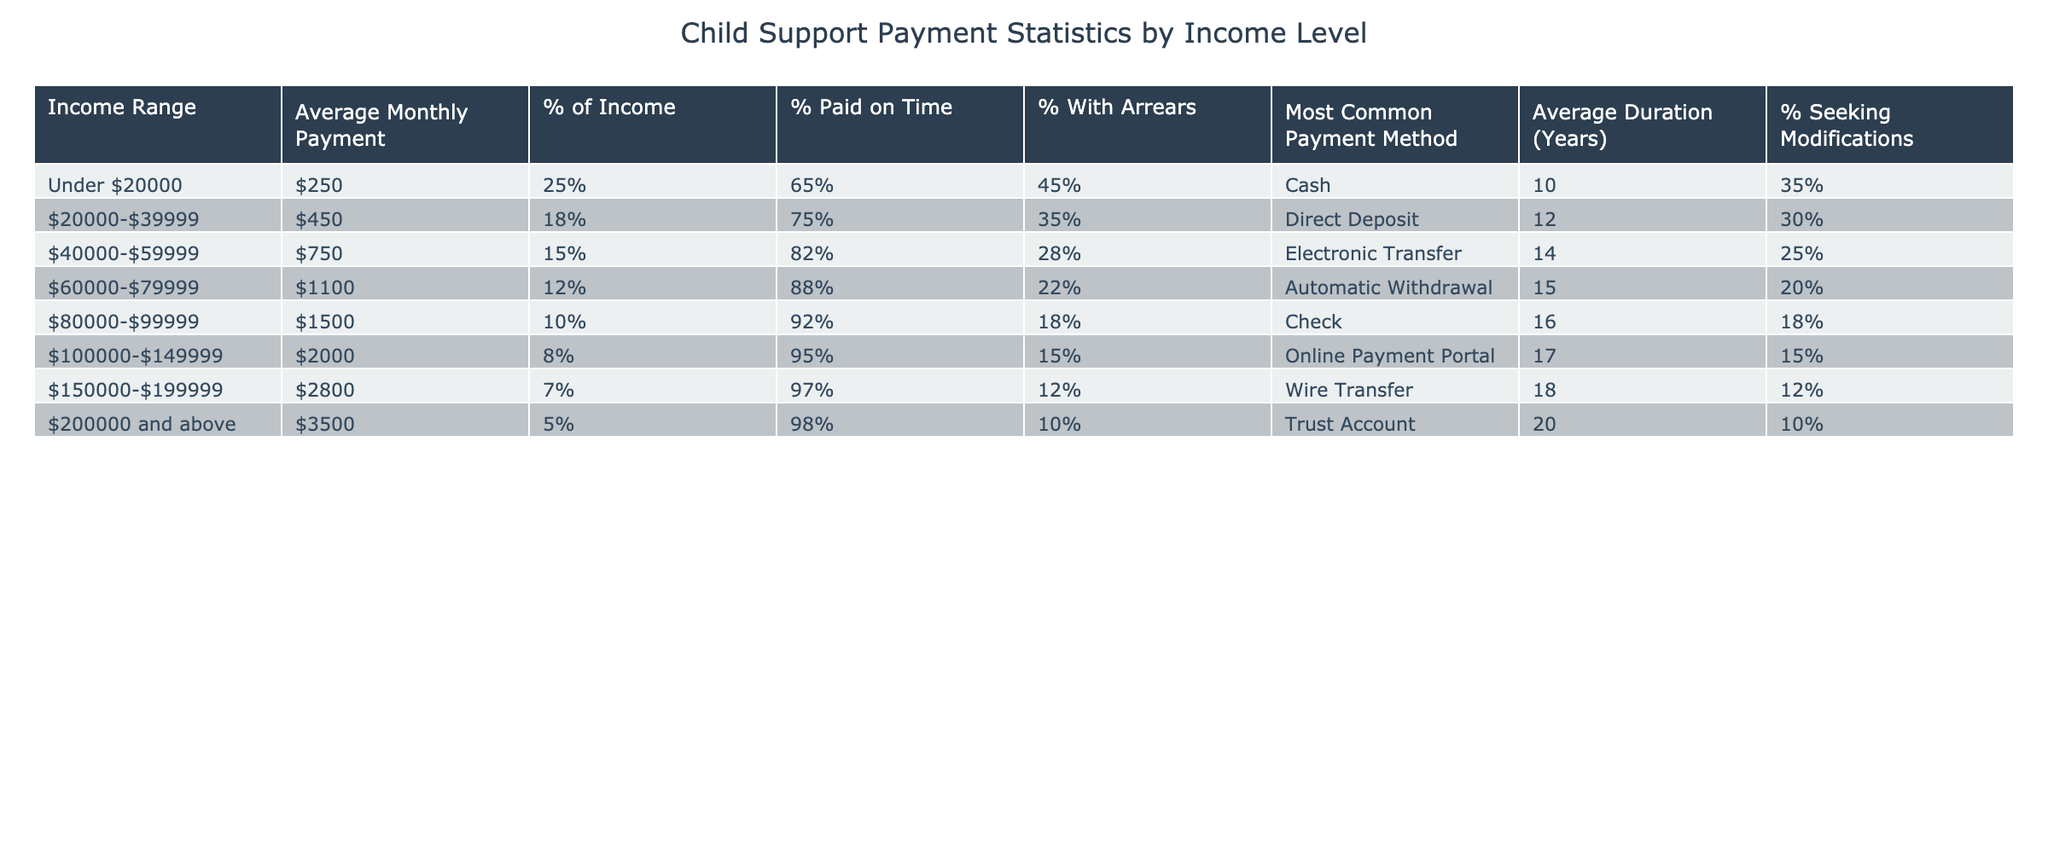What is the average monthly payment for parents earning under $20,000? According to the table, the average monthly payment for this income range is $250.
Answer: $250 What percentage of income does the average payment represent for the $100,000-$149,999 income range? The table indicates that the average payment for this range is 8% of income.
Answer: 8% Which income range has the highest percentage of timely payments? Looking at the table, the income range of $100,000-$149,999 has the highest percentage of timely payments at 95%.
Answer: $100,000-$149,999 What is the most common payment method for the $20,000-$39,999 income range? The table shows that the most common payment method for this range is Direct Deposit.
Answer: Direct Deposit How many years on average do parents at the $200,000 and above income level pay child support? According to the table, the average duration for this income level is 20 years.
Answer: 20 years What is the difference in the average monthly payment between the $60,000-$79,999 and the $80,000-$99,999 income ranges? The average payment for $60,000-$79,999 is $1,100 and for $80,000-$99,999 it is $1,500. The difference is $1,500 - $1,100 = $400.
Answer: $400 What percentage of parents earning $40,000-$59,999 have child support arrears? According to the table, the percentage of parents in this income range with arrears is 28%.
Answer: 28% Which income range exhibits the highest percentage of parents seeking modifications to their child support payments? By examining the table, it shows that the $20,000-$39,999 income range has 30% seeking modifications, which is the highest percentage.
Answer: $20,000-$39,999 If we compare the average monthly payment and average duration for the $150,000-$199,999 income group, what does this imply about their financial responsibility over time? The average payment for this group is $2,800 and the duration is 18 years. This implies that they are managing larger payments over a longer period, suggesting a commitment to fulfilling their financial responsibilities.
Answer: They manage larger payments over a longer period Is the average monthly payment for parents earning $200,000 and above the highest in the table? The average payment for this income range is $3,500, which is indeed the highest compared to other ranges listed in the table.
Answer: Yes 